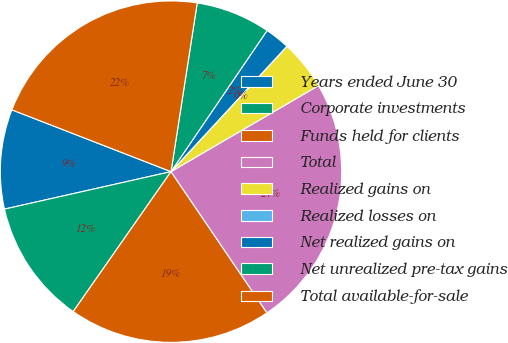<chart> <loc_0><loc_0><loc_500><loc_500><pie_chart><fcel>Years ended June 30<fcel>Corporate investments<fcel>Funds held for clients<fcel>Total<fcel>Realized gains on<fcel>Realized losses on<fcel>Net realized gains on<fcel>Net unrealized pre-tax gains<fcel>Total available-for-sale<nl><fcel>9.42%<fcel>11.77%<fcel>19.21%<fcel>23.91%<fcel>4.71%<fcel>0.01%<fcel>2.36%<fcel>7.06%<fcel>21.56%<nl></chart> 